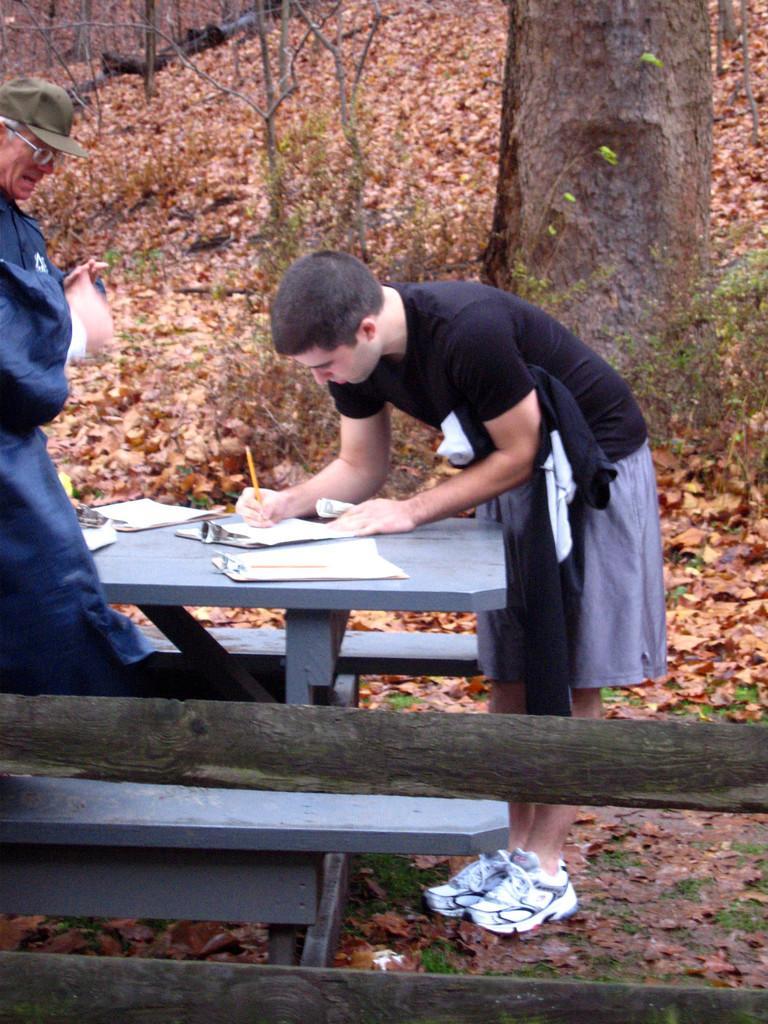Can you describe this image briefly? It's an outdoor place where one person is writing something on the paper on the table. One person is standing he is wearing a cap and glasses, the person is wearing shoes behind them so many leaves are present on the ground. 